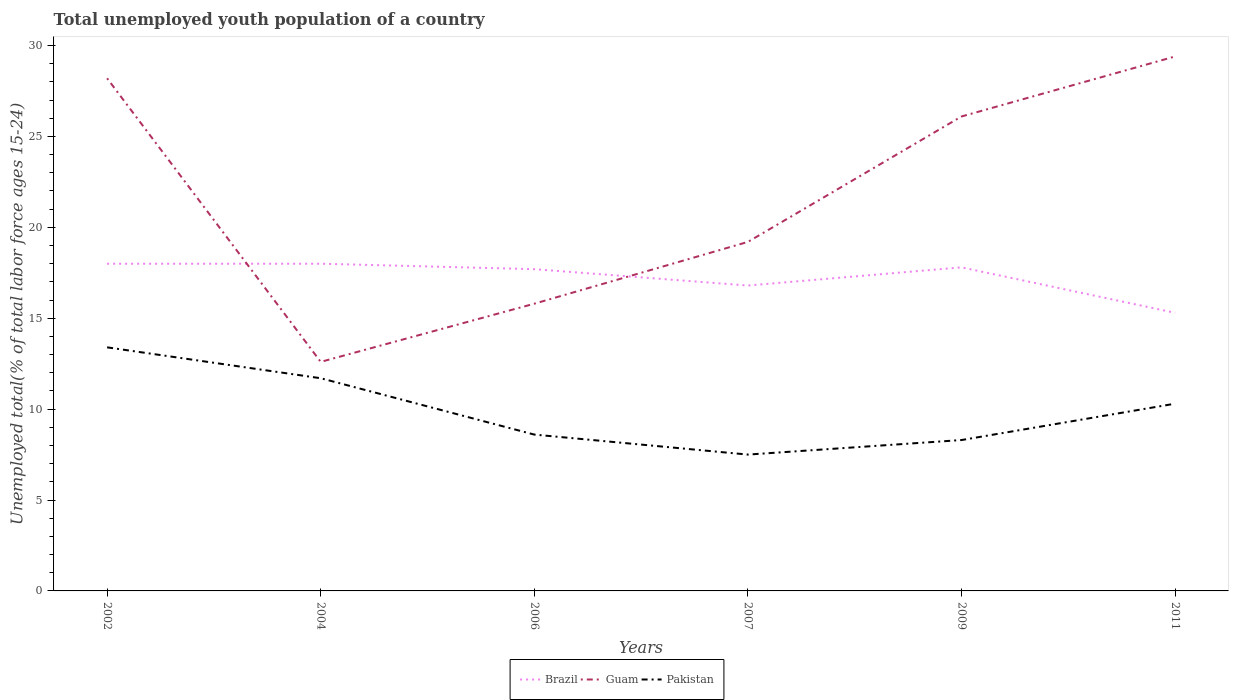How many different coloured lines are there?
Provide a succinct answer. 3. Is the number of lines equal to the number of legend labels?
Keep it short and to the point. Yes. Across all years, what is the maximum percentage of total unemployed youth population of a country in Brazil?
Offer a terse response. 15.3. What is the total percentage of total unemployed youth population of a country in Brazil in the graph?
Your response must be concise. -1. What is the difference between the highest and the second highest percentage of total unemployed youth population of a country in Pakistan?
Ensure brevity in your answer.  5.9. Is the percentage of total unemployed youth population of a country in Brazil strictly greater than the percentage of total unemployed youth population of a country in Guam over the years?
Provide a short and direct response. No. How many years are there in the graph?
Ensure brevity in your answer.  6. What is the difference between two consecutive major ticks on the Y-axis?
Your answer should be compact. 5. Does the graph contain any zero values?
Give a very brief answer. No. Does the graph contain grids?
Ensure brevity in your answer.  No. What is the title of the graph?
Offer a terse response. Total unemployed youth population of a country. Does "Saudi Arabia" appear as one of the legend labels in the graph?
Your answer should be compact. No. What is the label or title of the X-axis?
Make the answer very short. Years. What is the label or title of the Y-axis?
Keep it short and to the point. Unemployed total(% of total labor force ages 15-24). What is the Unemployed total(% of total labor force ages 15-24) in Guam in 2002?
Your answer should be compact. 28.2. What is the Unemployed total(% of total labor force ages 15-24) in Pakistan in 2002?
Give a very brief answer. 13.4. What is the Unemployed total(% of total labor force ages 15-24) in Brazil in 2004?
Your answer should be very brief. 18. What is the Unemployed total(% of total labor force ages 15-24) in Guam in 2004?
Offer a very short reply. 12.6. What is the Unemployed total(% of total labor force ages 15-24) of Pakistan in 2004?
Offer a terse response. 11.7. What is the Unemployed total(% of total labor force ages 15-24) in Brazil in 2006?
Provide a succinct answer. 17.7. What is the Unemployed total(% of total labor force ages 15-24) in Guam in 2006?
Your response must be concise. 15.8. What is the Unemployed total(% of total labor force ages 15-24) of Pakistan in 2006?
Offer a very short reply. 8.6. What is the Unemployed total(% of total labor force ages 15-24) in Brazil in 2007?
Keep it short and to the point. 16.8. What is the Unemployed total(% of total labor force ages 15-24) of Guam in 2007?
Your answer should be compact. 19.2. What is the Unemployed total(% of total labor force ages 15-24) of Brazil in 2009?
Give a very brief answer. 17.8. What is the Unemployed total(% of total labor force ages 15-24) in Guam in 2009?
Provide a succinct answer. 26.1. What is the Unemployed total(% of total labor force ages 15-24) of Pakistan in 2009?
Your answer should be compact. 8.3. What is the Unemployed total(% of total labor force ages 15-24) of Brazil in 2011?
Your answer should be compact. 15.3. What is the Unemployed total(% of total labor force ages 15-24) of Guam in 2011?
Provide a succinct answer. 29.4. What is the Unemployed total(% of total labor force ages 15-24) of Pakistan in 2011?
Provide a succinct answer. 10.3. Across all years, what is the maximum Unemployed total(% of total labor force ages 15-24) of Guam?
Make the answer very short. 29.4. Across all years, what is the maximum Unemployed total(% of total labor force ages 15-24) of Pakistan?
Ensure brevity in your answer.  13.4. Across all years, what is the minimum Unemployed total(% of total labor force ages 15-24) in Brazil?
Give a very brief answer. 15.3. Across all years, what is the minimum Unemployed total(% of total labor force ages 15-24) of Guam?
Give a very brief answer. 12.6. What is the total Unemployed total(% of total labor force ages 15-24) in Brazil in the graph?
Provide a short and direct response. 103.6. What is the total Unemployed total(% of total labor force ages 15-24) of Guam in the graph?
Provide a succinct answer. 131.3. What is the total Unemployed total(% of total labor force ages 15-24) in Pakistan in the graph?
Make the answer very short. 59.8. What is the difference between the Unemployed total(% of total labor force ages 15-24) in Guam in 2002 and that in 2006?
Provide a short and direct response. 12.4. What is the difference between the Unemployed total(% of total labor force ages 15-24) of Pakistan in 2002 and that in 2006?
Provide a short and direct response. 4.8. What is the difference between the Unemployed total(% of total labor force ages 15-24) in Guam in 2002 and that in 2007?
Provide a succinct answer. 9. What is the difference between the Unemployed total(% of total labor force ages 15-24) in Pakistan in 2002 and that in 2007?
Offer a terse response. 5.9. What is the difference between the Unemployed total(% of total labor force ages 15-24) in Brazil in 2002 and that in 2009?
Offer a very short reply. 0.2. What is the difference between the Unemployed total(% of total labor force ages 15-24) in Guam in 2002 and that in 2009?
Offer a terse response. 2.1. What is the difference between the Unemployed total(% of total labor force ages 15-24) in Pakistan in 2002 and that in 2009?
Provide a succinct answer. 5.1. What is the difference between the Unemployed total(% of total labor force ages 15-24) of Guam in 2002 and that in 2011?
Keep it short and to the point. -1.2. What is the difference between the Unemployed total(% of total labor force ages 15-24) in Guam in 2004 and that in 2006?
Provide a short and direct response. -3.2. What is the difference between the Unemployed total(% of total labor force ages 15-24) in Guam in 2004 and that in 2007?
Make the answer very short. -6.6. What is the difference between the Unemployed total(% of total labor force ages 15-24) in Pakistan in 2004 and that in 2007?
Offer a very short reply. 4.2. What is the difference between the Unemployed total(% of total labor force ages 15-24) in Brazil in 2004 and that in 2009?
Provide a succinct answer. 0.2. What is the difference between the Unemployed total(% of total labor force ages 15-24) of Guam in 2004 and that in 2009?
Offer a terse response. -13.5. What is the difference between the Unemployed total(% of total labor force ages 15-24) of Guam in 2004 and that in 2011?
Your answer should be very brief. -16.8. What is the difference between the Unemployed total(% of total labor force ages 15-24) of Brazil in 2006 and that in 2007?
Give a very brief answer. 0.9. What is the difference between the Unemployed total(% of total labor force ages 15-24) of Guam in 2006 and that in 2007?
Offer a very short reply. -3.4. What is the difference between the Unemployed total(% of total labor force ages 15-24) in Brazil in 2006 and that in 2009?
Ensure brevity in your answer.  -0.1. What is the difference between the Unemployed total(% of total labor force ages 15-24) of Guam in 2006 and that in 2009?
Ensure brevity in your answer.  -10.3. What is the difference between the Unemployed total(% of total labor force ages 15-24) in Pakistan in 2006 and that in 2009?
Offer a very short reply. 0.3. What is the difference between the Unemployed total(% of total labor force ages 15-24) in Guam in 2006 and that in 2011?
Provide a succinct answer. -13.6. What is the difference between the Unemployed total(% of total labor force ages 15-24) of Guam in 2007 and that in 2009?
Keep it short and to the point. -6.9. What is the difference between the Unemployed total(% of total labor force ages 15-24) in Brazil in 2007 and that in 2011?
Provide a succinct answer. 1.5. What is the difference between the Unemployed total(% of total labor force ages 15-24) of Pakistan in 2009 and that in 2011?
Ensure brevity in your answer.  -2. What is the difference between the Unemployed total(% of total labor force ages 15-24) in Brazil in 2002 and the Unemployed total(% of total labor force ages 15-24) in Guam in 2004?
Give a very brief answer. 5.4. What is the difference between the Unemployed total(% of total labor force ages 15-24) in Brazil in 2002 and the Unemployed total(% of total labor force ages 15-24) in Pakistan in 2004?
Give a very brief answer. 6.3. What is the difference between the Unemployed total(% of total labor force ages 15-24) of Guam in 2002 and the Unemployed total(% of total labor force ages 15-24) of Pakistan in 2004?
Provide a short and direct response. 16.5. What is the difference between the Unemployed total(% of total labor force ages 15-24) of Brazil in 2002 and the Unemployed total(% of total labor force ages 15-24) of Guam in 2006?
Ensure brevity in your answer.  2.2. What is the difference between the Unemployed total(% of total labor force ages 15-24) of Guam in 2002 and the Unemployed total(% of total labor force ages 15-24) of Pakistan in 2006?
Provide a short and direct response. 19.6. What is the difference between the Unemployed total(% of total labor force ages 15-24) in Brazil in 2002 and the Unemployed total(% of total labor force ages 15-24) in Pakistan in 2007?
Keep it short and to the point. 10.5. What is the difference between the Unemployed total(% of total labor force ages 15-24) in Guam in 2002 and the Unemployed total(% of total labor force ages 15-24) in Pakistan in 2007?
Make the answer very short. 20.7. What is the difference between the Unemployed total(% of total labor force ages 15-24) of Brazil in 2002 and the Unemployed total(% of total labor force ages 15-24) of Guam in 2011?
Give a very brief answer. -11.4. What is the difference between the Unemployed total(% of total labor force ages 15-24) in Guam in 2002 and the Unemployed total(% of total labor force ages 15-24) in Pakistan in 2011?
Your response must be concise. 17.9. What is the difference between the Unemployed total(% of total labor force ages 15-24) of Guam in 2004 and the Unemployed total(% of total labor force ages 15-24) of Pakistan in 2006?
Offer a terse response. 4. What is the difference between the Unemployed total(% of total labor force ages 15-24) of Brazil in 2004 and the Unemployed total(% of total labor force ages 15-24) of Pakistan in 2007?
Ensure brevity in your answer.  10.5. What is the difference between the Unemployed total(% of total labor force ages 15-24) of Brazil in 2004 and the Unemployed total(% of total labor force ages 15-24) of Pakistan in 2011?
Your answer should be very brief. 7.7. What is the difference between the Unemployed total(% of total labor force ages 15-24) of Guam in 2004 and the Unemployed total(% of total labor force ages 15-24) of Pakistan in 2011?
Make the answer very short. 2.3. What is the difference between the Unemployed total(% of total labor force ages 15-24) of Brazil in 2006 and the Unemployed total(% of total labor force ages 15-24) of Guam in 2007?
Keep it short and to the point. -1.5. What is the difference between the Unemployed total(% of total labor force ages 15-24) of Brazil in 2006 and the Unemployed total(% of total labor force ages 15-24) of Pakistan in 2007?
Provide a succinct answer. 10.2. What is the difference between the Unemployed total(% of total labor force ages 15-24) of Brazil in 2006 and the Unemployed total(% of total labor force ages 15-24) of Guam in 2011?
Your response must be concise. -11.7. What is the difference between the Unemployed total(% of total labor force ages 15-24) of Brazil in 2007 and the Unemployed total(% of total labor force ages 15-24) of Guam in 2009?
Provide a succinct answer. -9.3. What is the difference between the Unemployed total(% of total labor force ages 15-24) in Brazil in 2007 and the Unemployed total(% of total labor force ages 15-24) in Guam in 2011?
Give a very brief answer. -12.6. What is the difference between the Unemployed total(% of total labor force ages 15-24) of Brazil in 2007 and the Unemployed total(% of total labor force ages 15-24) of Pakistan in 2011?
Make the answer very short. 6.5. What is the difference between the Unemployed total(% of total labor force ages 15-24) in Guam in 2007 and the Unemployed total(% of total labor force ages 15-24) in Pakistan in 2011?
Offer a very short reply. 8.9. What is the difference between the Unemployed total(% of total labor force ages 15-24) of Brazil in 2009 and the Unemployed total(% of total labor force ages 15-24) of Guam in 2011?
Your answer should be very brief. -11.6. What is the difference between the Unemployed total(% of total labor force ages 15-24) of Brazil in 2009 and the Unemployed total(% of total labor force ages 15-24) of Pakistan in 2011?
Keep it short and to the point. 7.5. What is the difference between the Unemployed total(% of total labor force ages 15-24) of Guam in 2009 and the Unemployed total(% of total labor force ages 15-24) of Pakistan in 2011?
Ensure brevity in your answer.  15.8. What is the average Unemployed total(% of total labor force ages 15-24) of Brazil per year?
Provide a short and direct response. 17.27. What is the average Unemployed total(% of total labor force ages 15-24) in Guam per year?
Keep it short and to the point. 21.88. What is the average Unemployed total(% of total labor force ages 15-24) of Pakistan per year?
Keep it short and to the point. 9.97. In the year 2002, what is the difference between the Unemployed total(% of total labor force ages 15-24) in Guam and Unemployed total(% of total labor force ages 15-24) in Pakistan?
Offer a terse response. 14.8. In the year 2004, what is the difference between the Unemployed total(% of total labor force ages 15-24) in Brazil and Unemployed total(% of total labor force ages 15-24) in Guam?
Provide a succinct answer. 5.4. In the year 2004, what is the difference between the Unemployed total(% of total labor force ages 15-24) in Brazil and Unemployed total(% of total labor force ages 15-24) in Pakistan?
Your answer should be very brief. 6.3. In the year 2006, what is the difference between the Unemployed total(% of total labor force ages 15-24) of Brazil and Unemployed total(% of total labor force ages 15-24) of Pakistan?
Your answer should be very brief. 9.1. In the year 2006, what is the difference between the Unemployed total(% of total labor force ages 15-24) in Guam and Unemployed total(% of total labor force ages 15-24) in Pakistan?
Keep it short and to the point. 7.2. In the year 2007, what is the difference between the Unemployed total(% of total labor force ages 15-24) of Brazil and Unemployed total(% of total labor force ages 15-24) of Pakistan?
Your response must be concise. 9.3. In the year 2009, what is the difference between the Unemployed total(% of total labor force ages 15-24) in Guam and Unemployed total(% of total labor force ages 15-24) in Pakistan?
Keep it short and to the point. 17.8. In the year 2011, what is the difference between the Unemployed total(% of total labor force ages 15-24) in Brazil and Unemployed total(% of total labor force ages 15-24) in Guam?
Make the answer very short. -14.1. In the year 2011, what is the difference between the Unemployed total(% of total labor force ages 15-24) of Brazil and Unemployed total(% of total labor force ages 15-24) of Pakistan?
Your answer should be compact. 5. In the year 2011, what is the difference between the Unemployed total(% of total labor force ages 15-24) in Guam and Unemployed total(% of total labor force ages 15-24) in Pakistan?
Provide a short and direct response. 19.1. What is the ratio of the Unemployed total(% of total labor force ages 15-24) in Guam in 2002 to that in 2004?
Offer a terse response. 2.24. What is the ratio of the Unemployed total(% of total labor force ages 15-24) in Pakistan in 2002 to that in 2004?
Keep it short and to the point. 1.15. What is the ratio of the Unemployed total(% of total labor force ages 15-24) in Brazil in 2002 to that in 2006?
Your response must be concise. 1.02. What is the ratio of the Unemployed total(% of total labor force ages 15-24) in Guam in 2002 to that in 2006?
Offer a very short reply. 1.78. What is the ratio of the Unemployed total(% of total labor force ages 15-24) of Pakistan in 2002 to that in 2006?
Your response must be concise. 1.56. What is the ratio of the Unemployed total(% of total labor force ages 15-24) of Brazil in 2002 to that in 2007?
Your answer should be compact. 1.07. What is the ratio of the Unemployed total(% of total labor force ages 15-24) in Guam in 2002 to that in 2007?
Keep it short and to the point. 1.47. What is the ratio of the Unemployed total(% of total labor force ages 15-24) of Pakistan in 2002 to that in 2007?
Your answer should be compact. 1.79. What is the ratio of the Unemployed total(% of total labor force ages 15-24) of Brazil in 2002 to that in 2009?
Your answer should be very brief. 1.01. What is the ratio of the Unemployed total(% of total labor force ages 15-24) of Guam in 2002 to that in 2009?
Your response must be concise. 1.08. What is the ratio of the Unemployed total(% of total labor force ages 15-24) of Pakistan in 2002 to that in 2009?
Provide a short and direct response. 1.61. What is the ratio of the Unemployed total(% of total labor force ages 15-24) in Brazil in 2002 to that in 2011?
Give a very brief answer. 1.18. What is the ratio of the Unemployed total(% of total labor force ages 15-24) of Guam in 2002 to that in 2011?
Give a very brief answer. 0.96. What is the ratio of the Unemployed total(% of total labor force ages 15-24) of Pakistan in 2002 to that in 2011?
Keep it short and to the point. 1.3. What is the ratio of the Unemployed total(% of total labor force ages 15-24) of Brazil in 2004 to that in 2006?
Ensure brevity in your answer.  1.02. What is the ratio of the Unemployed total(% of total labor force ages 15-24) of Guam in 2004 to that in 2006?
Offer a terse response. 0.8. What is the ratio of the Unemployed total(% of total labor force ages 15-24) of Pakistan in 2004 to that in 2006?
Your answer should be very brief. 1.36. What is the ratio of the Unemployed total(% of total labor force ages 15-24) of Brazil in 2004 to that in 2007?
Your answer should be very brief. 1.07. What is the ratio of the Unemployed total(% of total labor force ages 15-24) in Guam in 2004 to that in 2007?
Make the answer very short. 0.66. What is the ratio of the Unemployed total(% of total labor force ages 15-24) in Pakistan in 2004 to that in 2007?
Provide a succinct answer. 1.56. What is the ratio of the Unemployed total(% of total labor force ages 15-24) in Brazil in 2004 to that in 2009?
Provide a succinct answer. 1.01. What is the ratio of the Unemployed total(% of total labor force ages 15-24) of Guam in 2004 to that in 2009?
Your answer should be very brief. 0.48. What is the ratio of the Unemployed total(% of total labor force ages 15-24) in Pakistan in 2004 to that in 2009?
Your answer should be compact. 1.41. What is the ratio of the Unemployed total(% of total labor force ages 15-24) of Brazil in 2004 to that in 2011?
Provide a succinct answer. 1.18. What is the ratio of the Unemployed total(% of total labor force ages 15-24) of Guam in 2004 to that in 2011?
Ensure brevity in your answer.  0.43. What is the ratio of the Unemployed total(% of total labor force ages 15-24) of Pakistan in 2004 to that in 2011?
Your response must be concise. 1.14. What is the ratio of the Unemployed total(% of total labor force ages 15-24) of Brazil in 2006 to that in 2007?
Make the answer very short. 1.05. What is the ratio of the Unemployed total(% of total labor force ages 15-24) of Guam in 2006 to that in 2007?
Give a very brief answer. 0.82. What is the ratio of the Unemployed total(% of total labor force ages 15-24) in Pakistan in 2006 to that in 2007?
Keep it short and to the point. 1.15. What is the ratio of the Unemployed total(% of total labor force ages 15-24) of Brazil in 2006 to that in 2009?
Your response must be concise. 0.99. What is the ratio of the Unemployed total(% of total labor force ages 15-24) in Guam in 2006 to that in 2009?
Offer a terse response. 0.61. What is the ratio of the Unemployed total(% of total labor force ages 15-24) in Pakistan in 2006 to that in 2009?
Your answer should be compact. 1.04. What is the ratio of the Unemployed total(% of total labor force ages 15-24) of Brazil in 2006 to that in 2011?
Give a very brief answer. 1.16. What is the ratio of the Unemployed total(% of total labor force ages 15-24) of Guam in 2006 to that in 2011?
Offer a terse response. 0.54. What is the ratio of the Unemployed total(% of total labor force ages 15-24) in Pakistan in 2006 to that in 2011?
Offer a very short reply. 0.83. What is the ratio of the Unemployed total(% of total labor force ages 15-24) of Brazil in 2007 to that in 2009?
Your answer should be very brief. 0.94. What is the ratio of the Unemployed total(% of total labor force ages 15-24) of Guam in 2007 to that in 2009?
Keep it short and to the point. 0.74. What is the ratio of the Unemployed total(% of total labor force ages 15-24) of Pakistan in 2007 to that in 2009?
Provide a succinct answer. 0.9. What is the ratio of the Unemployed total(% of total labor force ages 15-24) in Brazil in 2007 to that in 2011?
Offer a very short reply. 1.1. What is the ratio of the Unemployed total(% of total labor force ages 15-24) of Guam in 2007 to that in 2011?
Offer a very short reply. 0.65. What is the ratio of the Unemployed total(% of total labor force ages 15-24) in Pakistan in 2007 to that in 2011?
Your answer should be very brief. 0.73. What is the ratio of the Unemployed total(% of total labor force ages 15-24) of Brazil in 2009 to that in 2011?
Offer a terse response. 1.16. What is the ratio of the Unemployed total(% of total labor force ages 15-24) in Guam in 2009 to that in 2011?
Offer a very short reply. 0.89. What is the ratio of the Unemployed total(% of total labor force ages 15-24) of Pakistan in 2009 to that in 2011?
Your answer should be very brief. 0.81. What is the difference between the highest and the second highest Unemployed total(% of total labor force ages 15-24) in Guam?
Make the answer very short. 1.2. What is the difference between the highest and the lowest Unemployed total(% of total labor force ages 15-24) of Brazil?
Provide a succinct answer. 2.7. What is the difference between the highest and the lowest Unemployed total(% of total labor force ages 15-24) in Pakistan?
Make the answer very short. 5.9. 